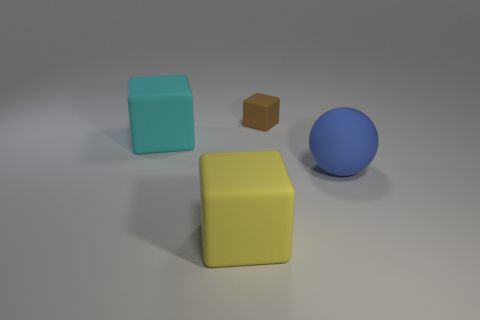What shape is the thing that is behind the blue object and left of the brown matte block?
Your answer should be very brief. Cube. Is the material of the big block that is behind the large yellow rubber cube the same as the large blue sphere?
Give a very brief answer. Yes. How many objects are either cyan matte things or large cubes in front of the blue sphere?
Your response must be concise. 2. There is a ball that is made of the same material as the big yellow cube; what color is it?
Keep it short and to the point. Blue. How many other large objects have the same material as the large cyan object?
Your answer should be compact. 2. What number of small red metallic cylinders are there?
Make the answer very short. 0. There is a rubber block to the right of the large yellow thing; does it have the same color as the big matte cube to the left of the yellow matte cube?
Your response must be concise. No. How many brown cubes are in front of the brown block?
Your response must be concise. 0. Is there another small brown rubber object that has the same shape as the tiny object?
Your answer should be very brief. No. Is the cube that is on the right side of the yellow rubber cube made of the same material as the thing that is right of the small brown block?
Ensure brevity in your answer.  Yes. 